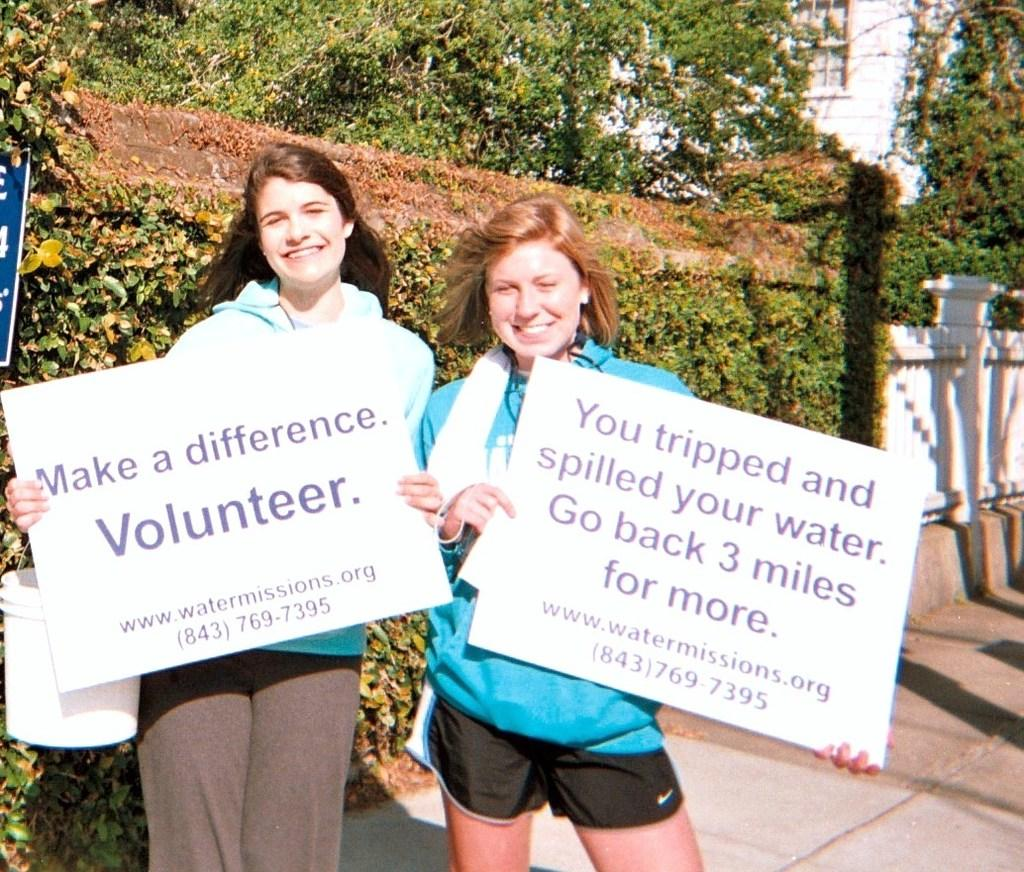How many people are in the image? There are two ladies in the image. What are the ladies holding in the image? The ladies are holding boards with text. What can be seen in the background of the image? There are trees in the background of the image. What type of structure is present in the image? There is fencing in the image. What is at the bottom of the image? There is a road at the bottom of the image. What type of feast is being prepared by the ladies in the image? There is no indication of a feast or any food preparation in the image. What achievements have the ladies accomplished, as indicated by the text on their boards? The text on the boards cannot be read in the image, so it is impossible to determine any achievements. 